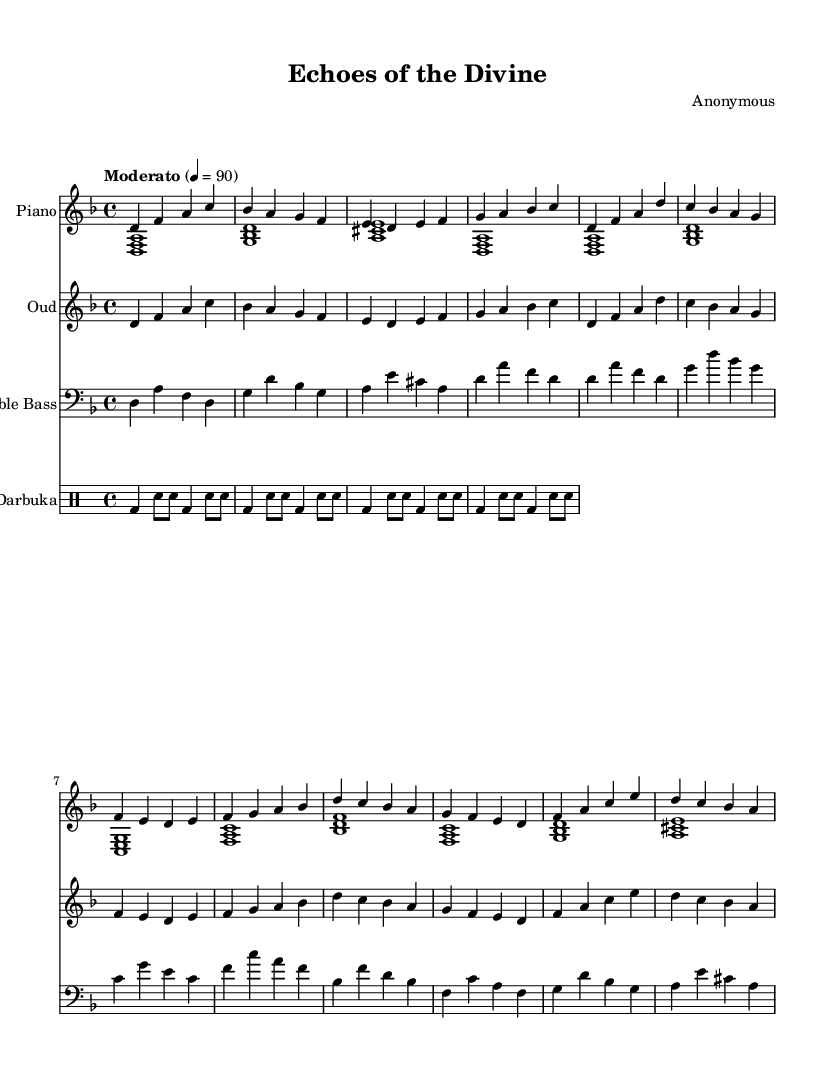What is the key signature of this music? The key signature is identified at the beginning of the staff, which shows two flats. This indicates that the music is in D minor.
Answer: D minor What is the time signature of the piece? The time signature is shown at the beginning of the score, indicating that there are four beats in every measure, which is represented as 4/4.
Answer: 4/4 What is the tempo marking for this piece? The tempo marking is provided above the staff, stating "Moderato" with a metronome marking of 90, which tells the performer to play at a moderate speed of 90 beats per minute.
Answer: Moderato How many instruments are present in this score? By counting the individual staves for each instrument in the score, we find five staves: Piano (two hands), Oud, Double Bass, and Darbuka.
Answer: Five What type of rhythm is used by the Darbuka? The rhythmic pattern for Darbuka is indicated using a specific notation that corresponds to a Maqsum rhythm, identified by the sequence of Dum and Tak sounds.
Answer: Maqsum In which section does the chorus start? By analyzing the structure of the score, the chorus can be identified as starting after the verse section, marked by a distinct change in the melodic pattern and is defined as the third section in the music.
Answer: Chorus What is the relative pitch interval for the Oud's intro? The intro for the Oud is based on a sequence of notes starting with D and using a series of pitches that ascend and descend, leading to the conclusion that it spans intervals mainly within a minor scale.
Answer: D 